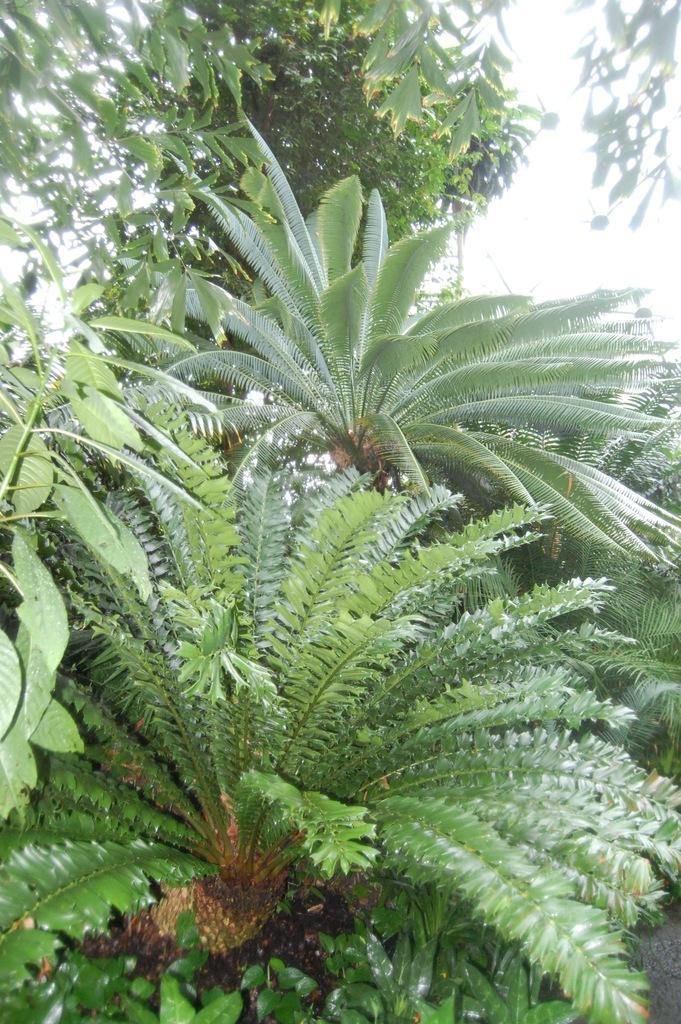Can you describe this image briefly? Here we can see plants and trees. In the background there is sky. 